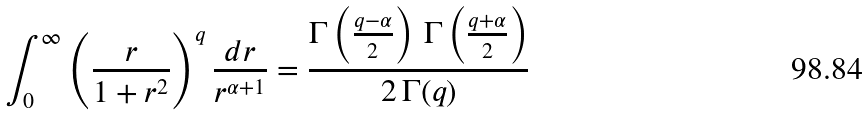<formula> <loc_0><loc_0><loc_500><loc_500>\int _ { 0 } ^ { \infty } \left ( \frac { r } { 1 + r ^ { 2 } } \right ) ^ { q } \frac { d r } { r ^ { \alpha + 1 } } = \frac { \Gamma \left ( \frac { q - \alpha } { 2 } \right ) \, \Gamma \left ( \frac { q + \alpha } { 2 } \right ) } { 2 \, \Gamma ( q ) }</formula> 